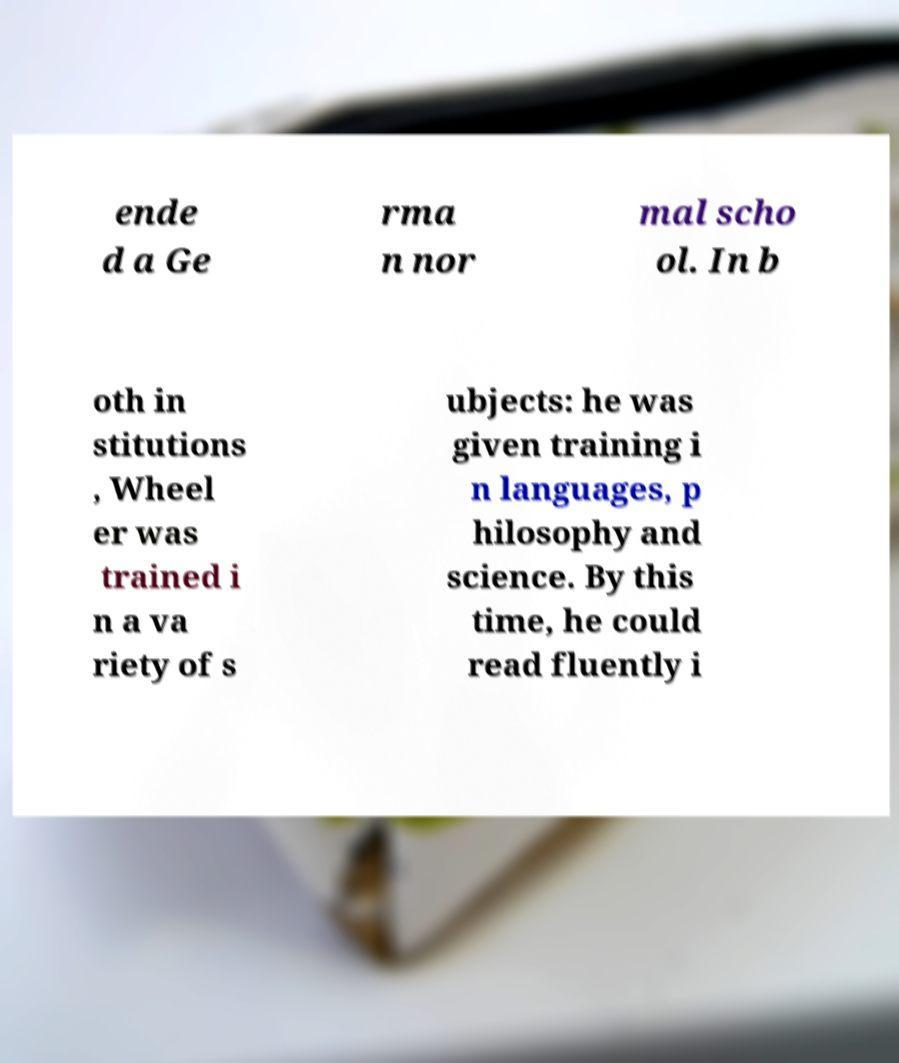What messages or text are displayed in this image? I need them in a readable, typed format. ende d a Ge rma n nor mal scho ol. In b oth in stitutions , Wheel er was trained i n a va riety of s ubjects: he was given training i n languages, p hilosophy and science. By this time, he could read fluently i 